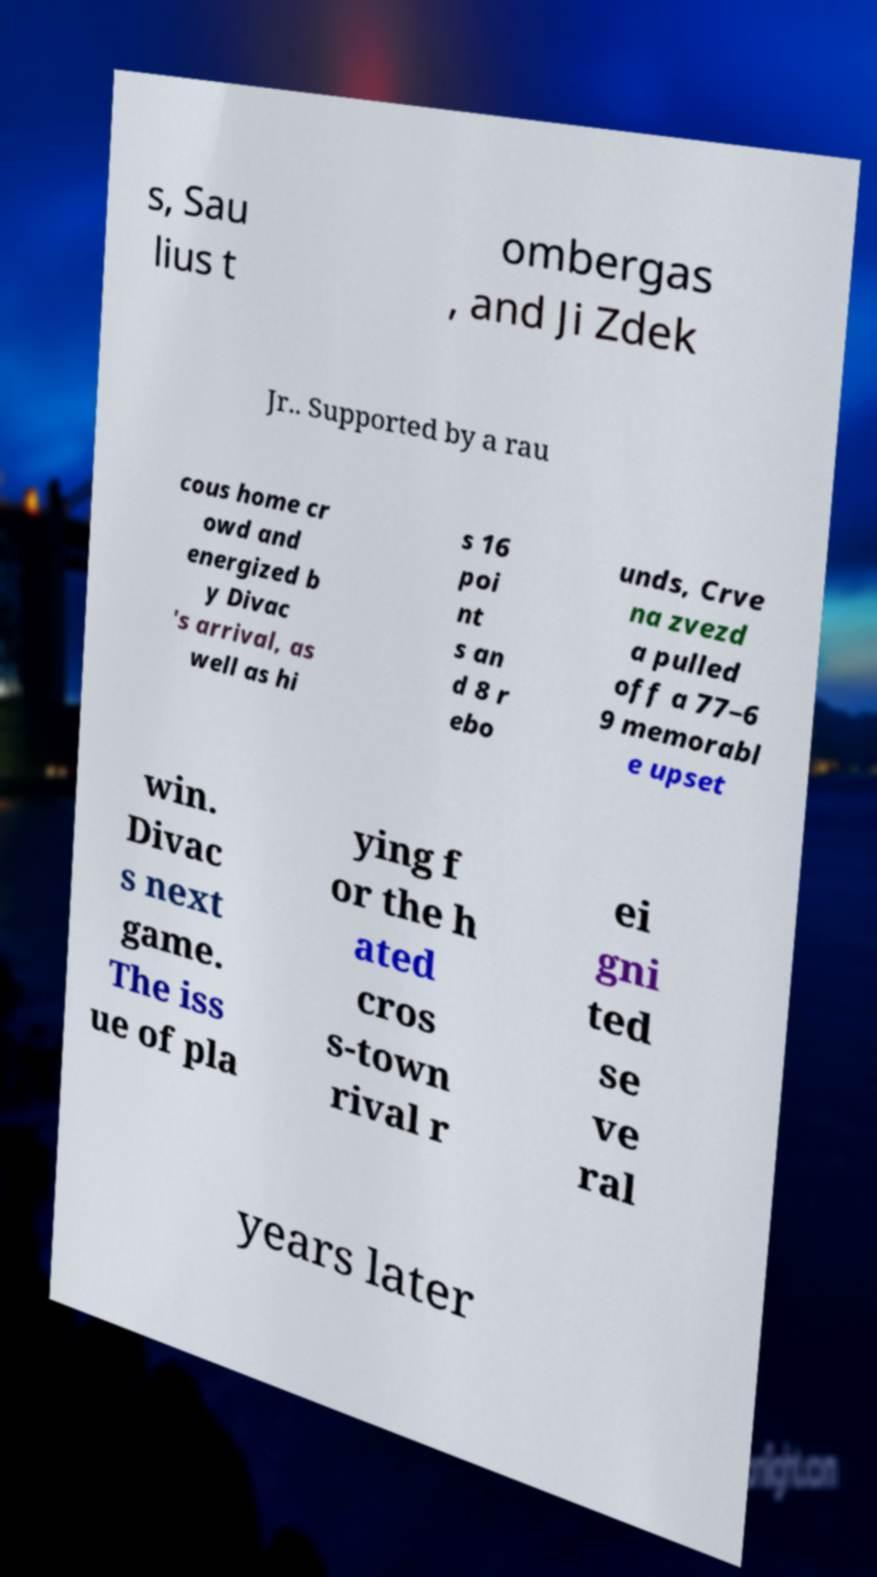For documentation purposes, I need the text within this image transcribed. Could you provide that? s, Sau lius t ombergas , and Ji Zdek Jr.. Supported by a rau cous home cr owd and energized b y Divac 's arrival, as well as hi s 16 poi nt s an d 8 r ebo unds, Crve na zvezd a pulled off a 77–6 9 memorabl e upset win. Divac s next game. The iss ue of pla ying f or the h ated cros s-town rival r ei gni ted se ve ral years later 